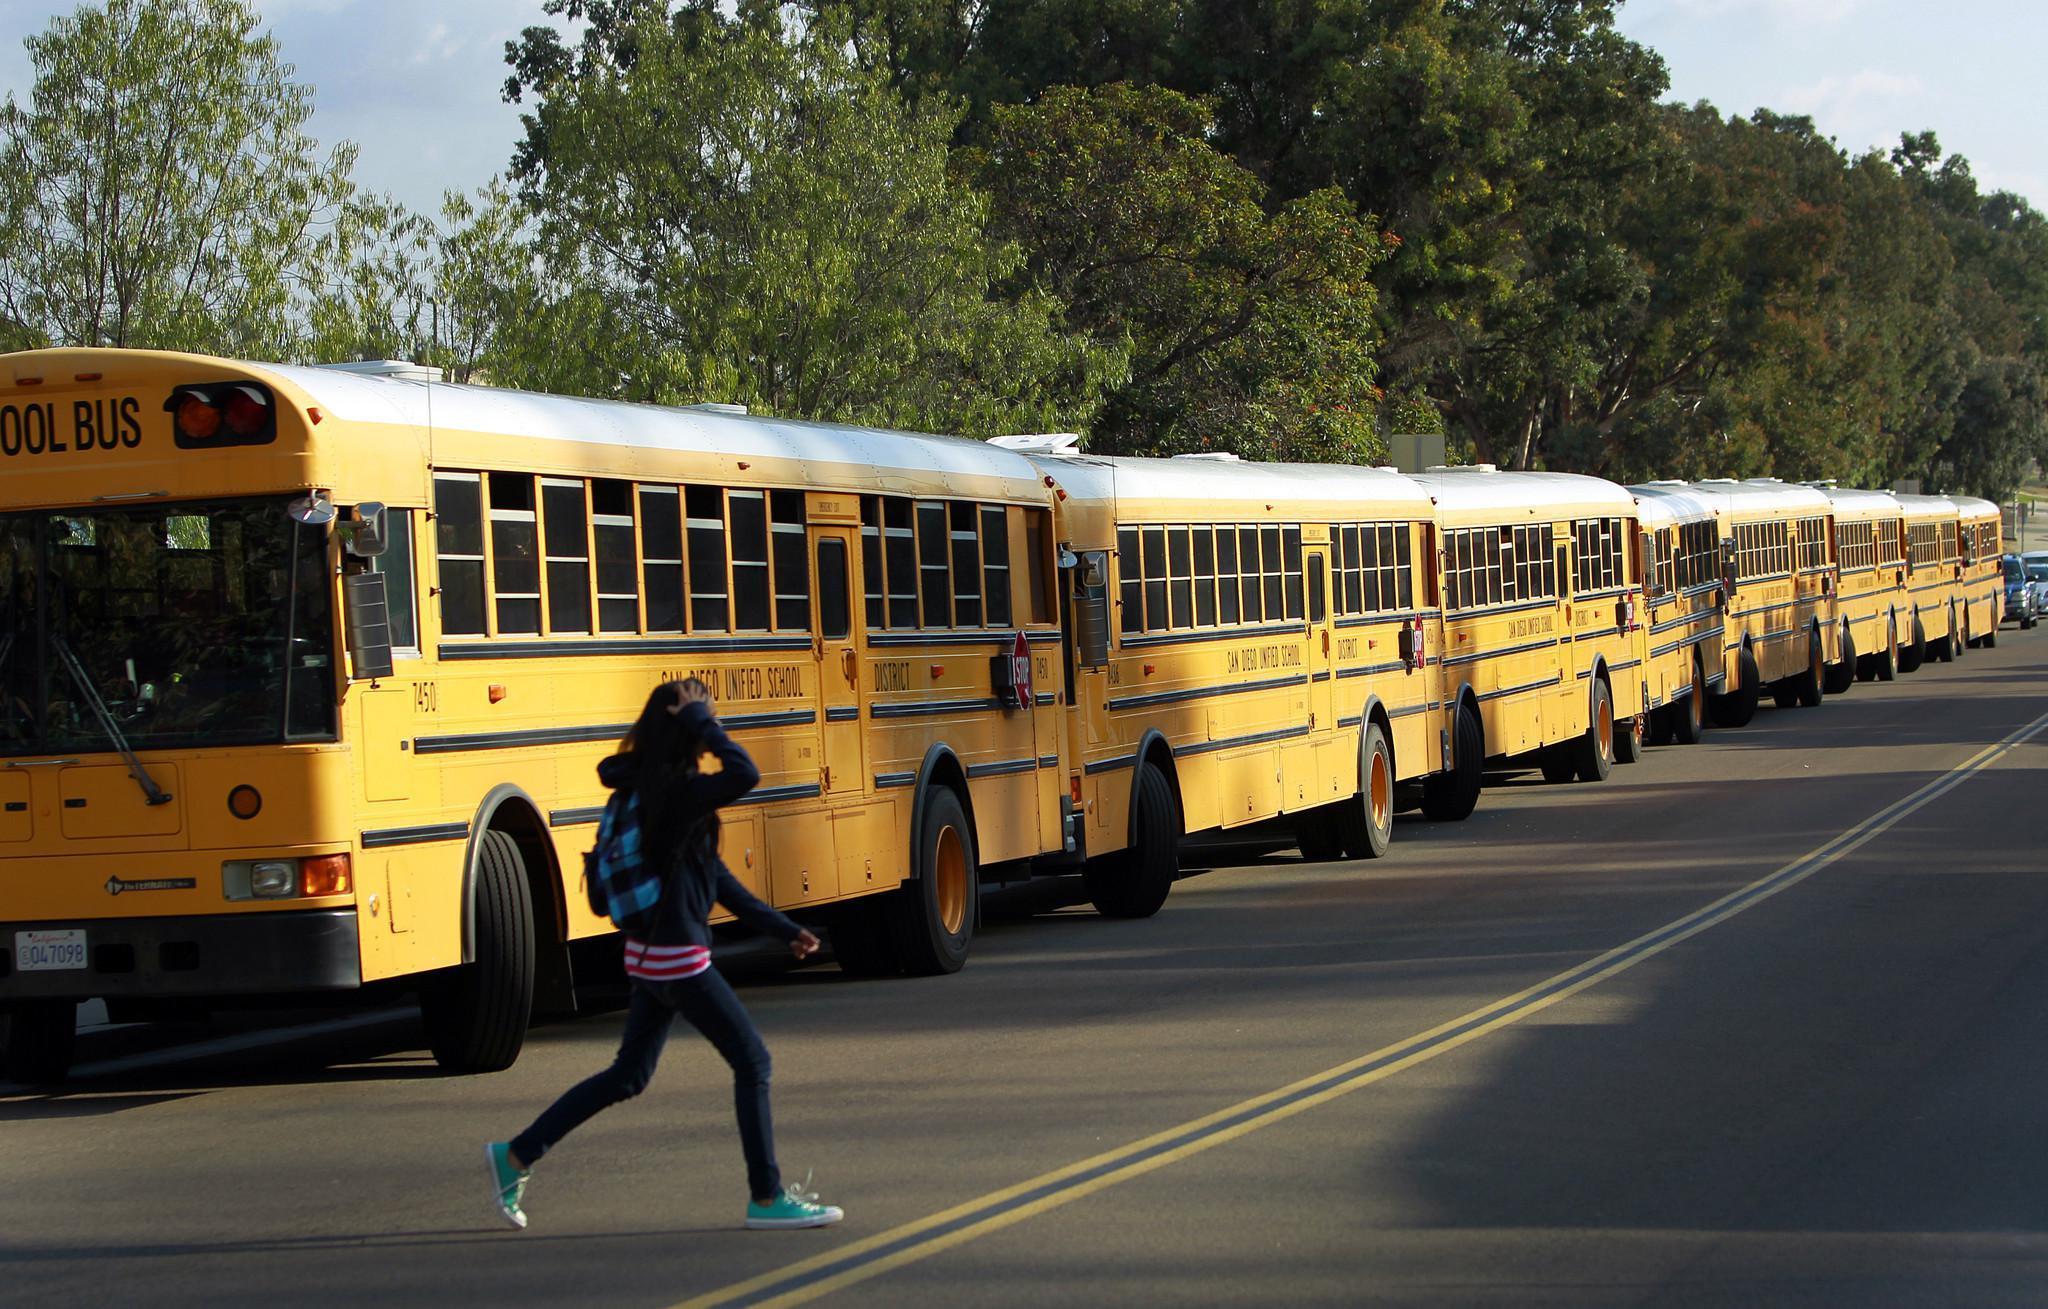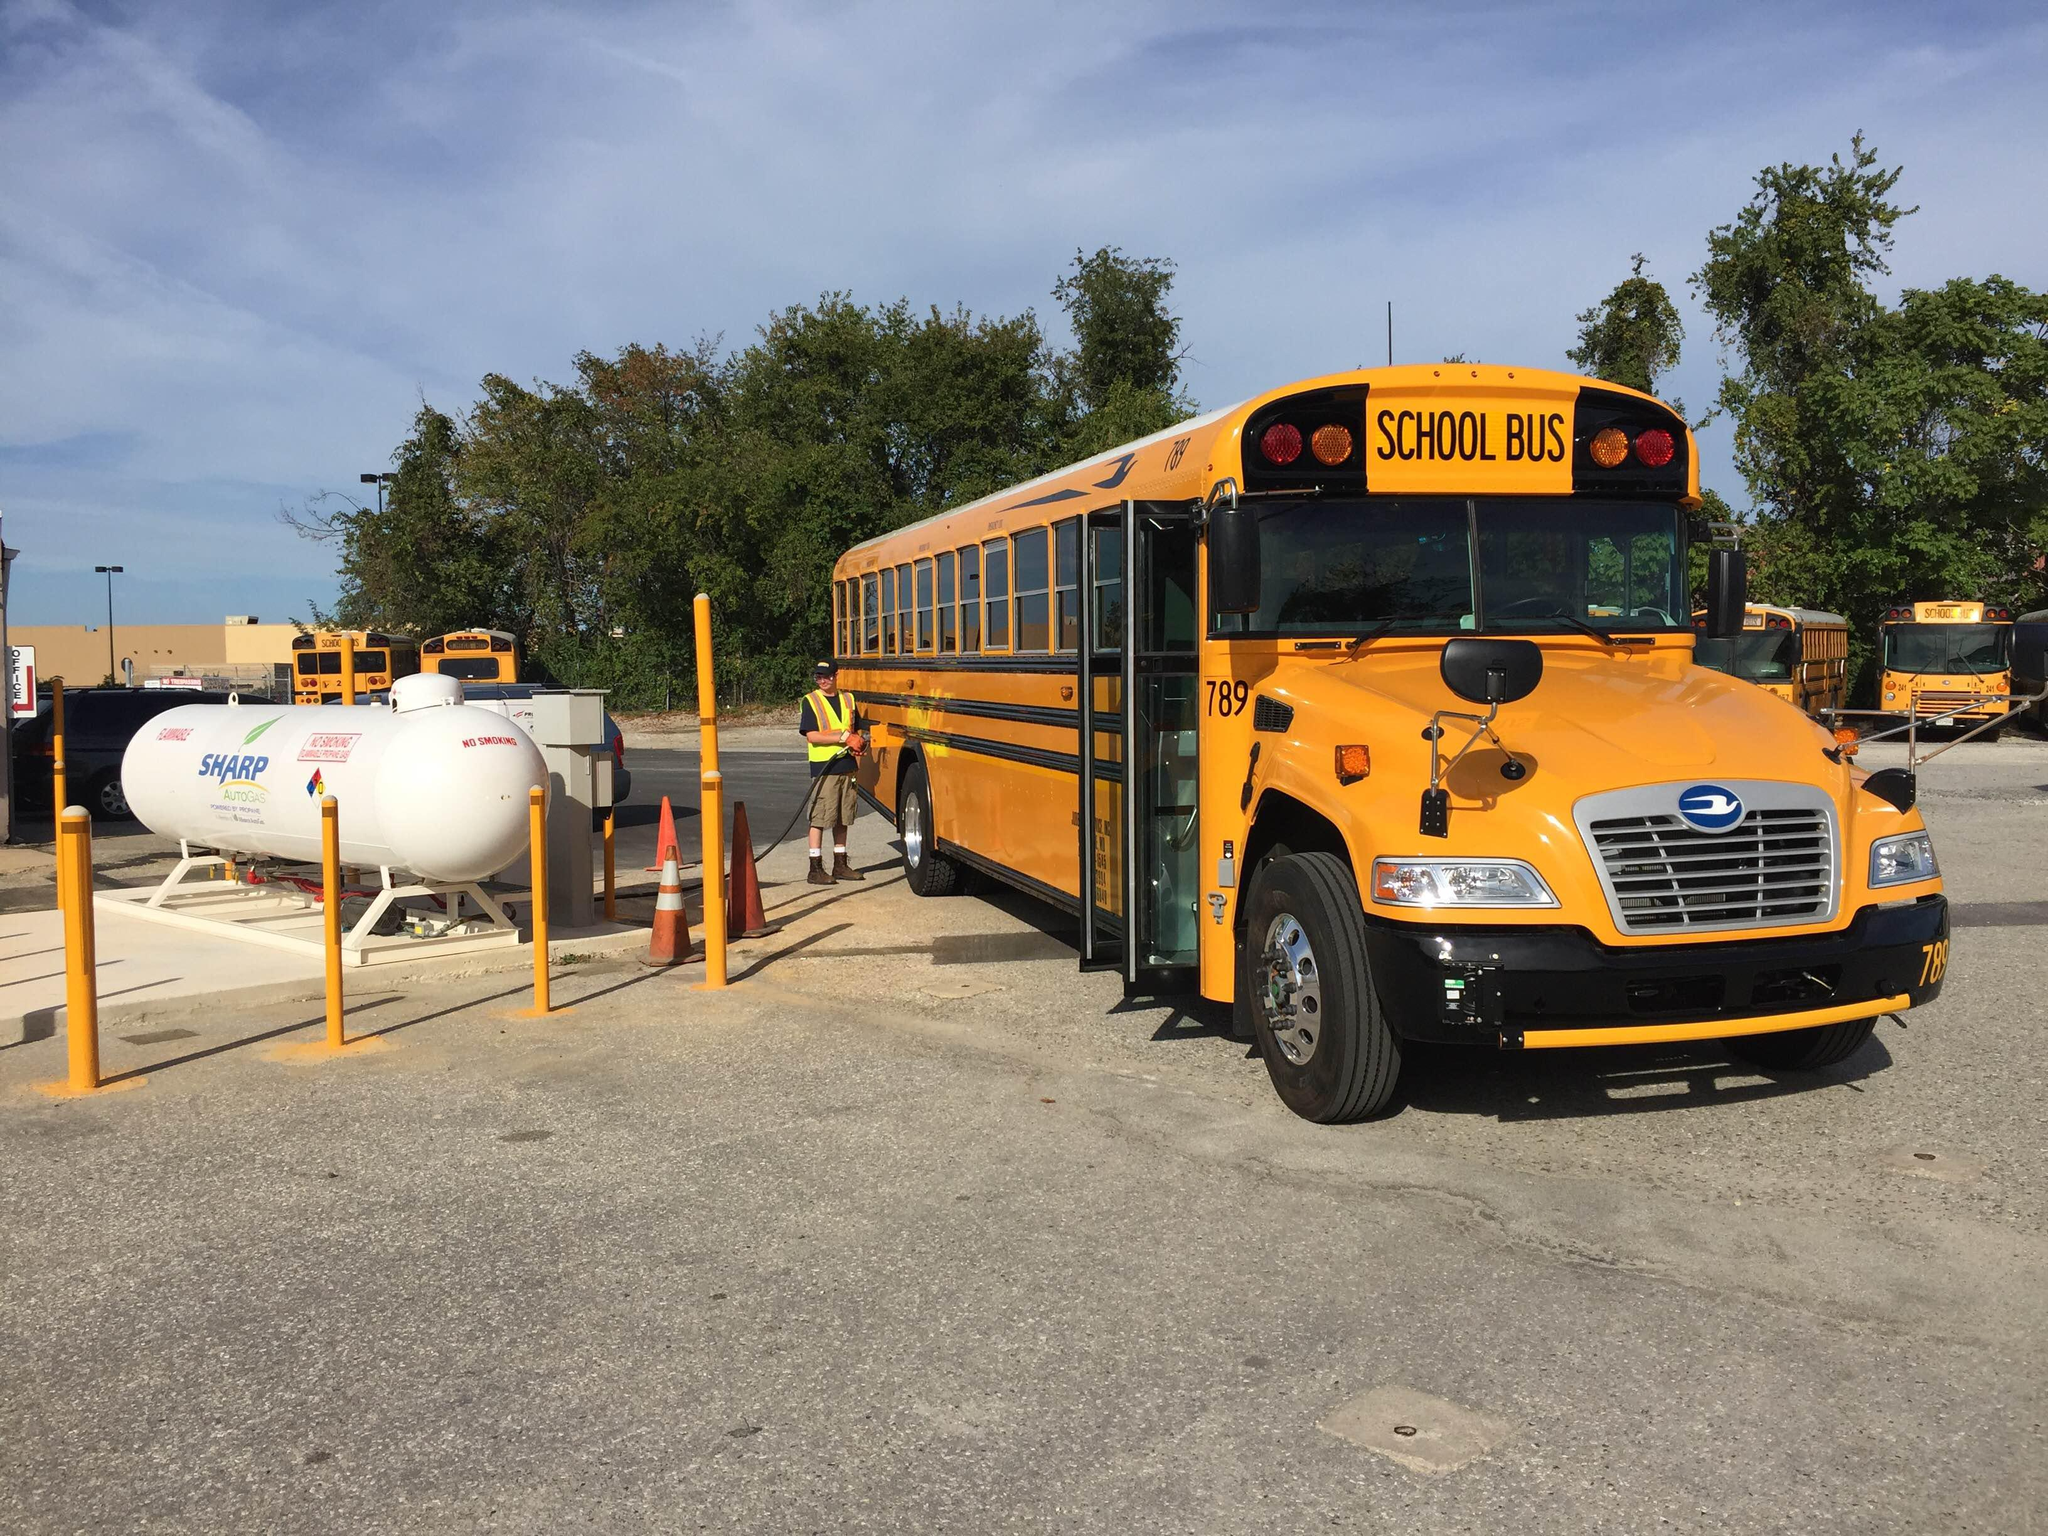The first image is the image on the left, the second image is the image on the right. Given the left and right images, does the statement "The left image features one flat-fronted bus parked at an angle in a parking lot, and the right image features a row of parked buses forming a diagonal line." hold true? Answer yes or no. No. 